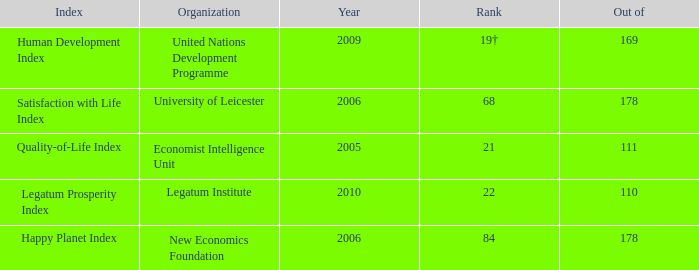What year is the happy planet index? 2006.0. 